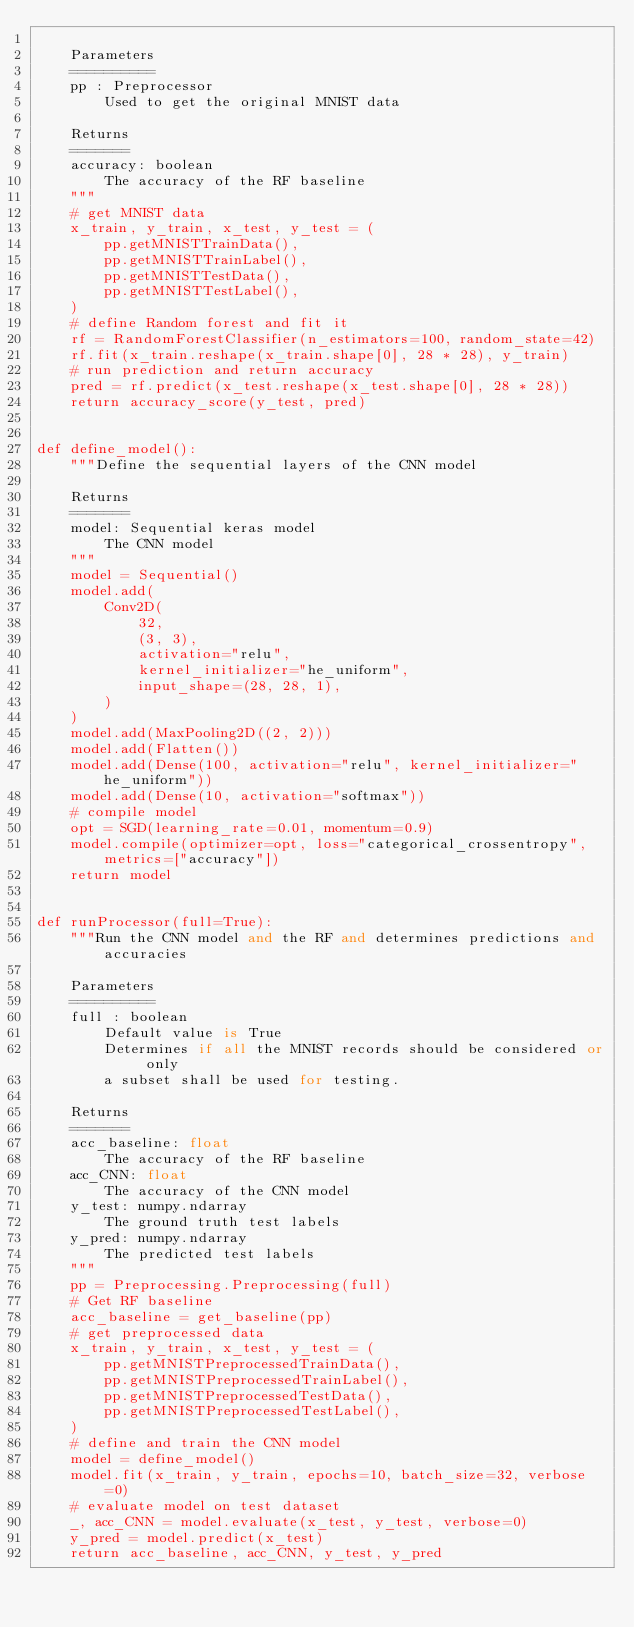Convert code to text. <code><loc_0><loc_0><loc_500><loc_500><_Python_>
    Parameters
    ==========
    pp : Preprocessor
        Used to get the original MNIST data

    Returns
    =======
    accuracy: boolean
        The accuracy of the RF baseline
    """
    # get MNIST data
    x_train, y_train, x_test, y_test = (
        pp.getMNISTTrainData(),
        pp.getMNISTTrainLabel(),
        pp.getMNISTTestData(),
        pp.getMNISTTestLabel(),
    )
    # define Random forest and fit it
    rf = RandomForestClassifier(n_estimators=100, random_state=42)
    rf.fit(x_train.reshape(x_train.shape[0], 28 * 28), y_train)
    # run prediction and return accuracy
    pred = rf.predict(x_test.reshape(x_test.shape[0], 28 * 28))
    return accuracy_score(y_test, pred)


def define_model():
    """Define the sequential layers of the CNN model

    Returns
    =======
    model: Sequential keras model
        The CNN model
    """
    model = Sequential()
    model.add(
        Conv2D(
            32,
            (3, 3),
            activation="relu",
            kernel_initializer="he_uniform",
            input_shape=(28, 28, 1),
        )
    )
    model.add(MaxPooling2D((2, 2)))
    model.add(Flatten())
    model.add(Dense(100, activation="relu", kernel_initializer="he_uniform"))
    model.add(Dense(10, activation="softmax"))
    # compile model
    opt = SGD(learning_rate=0.01, momentum=0.9)
    model.compile(optimizer=opt, loss="categorical_crossentropy", metrics=["accuracy"])
    return model


def runProcessor(full=True):
    """Run the CNN model and the RF and determines predictions and accuracies

    Parameters
    ==========
    full : boolean
        Default value is True
        Determines if all the MNIST records should be considered or only
        a subset shall be used for testing.

    Returns
    =======
    acc_baseline: float
        The accuracy of the RF baseline
    acc_CNN: float
        The accuracy of the CNN model
    y_test: numpy.ndarray
        The ground truth test labels
    y_pred: numpy.ndarray
        The predicted test labels
    """
    pp = Preprocessing.Preprocessing(full)
    # Get RF baseline
    acc_baseline = get_baseline(pp)
    # get preprocessed data
    x_train, y_train, x_test, y_test = (
        pp.getMNISTPreprocessedTrainData(),
        pp.getMNISTPreprocessedTrainLabel(),
        pp.getMNISTPreprocessedTestData(),
        pp.getMNISTPreprocessedTestLabel(),
    )
    # define and train the CNN model
    model = define_model()
    model.fit(x_train, y_train, epochs=10, batch_size=32, verbose=0)
    # evaluate model on test dataset
    _, acc_CNN = model.evaluate(x_test, y_test, verbose=0)
    y_pred = model.predict(x_test)
    return acc_baseline, acc_CNN, y_test, y_pred
</code> 